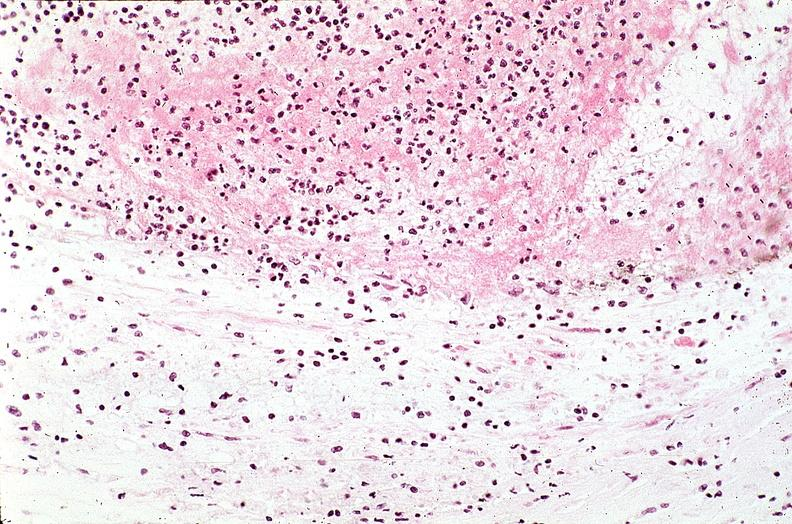does this image show coronary artery with atherosclerosis and thrombotic occlusion?
Answer the question using a single word or phrase. Yes 